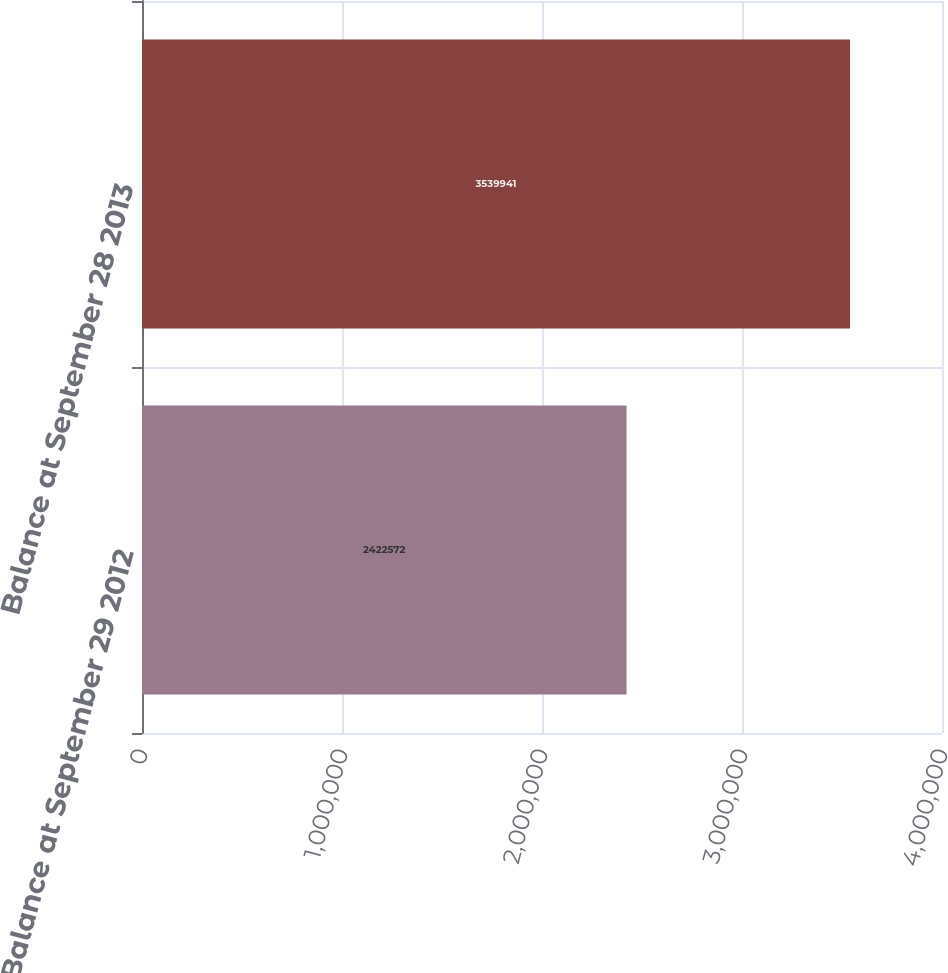Convert chart. <chart><loc_0><loc_0><loc_500><loc_500><bar_chart><fcel>Balance at September 29 2012<fcel>Balance at September 28 2013<nl><fcel>2.42257e+06<fcel>3.53994e+06<nl></chart> 